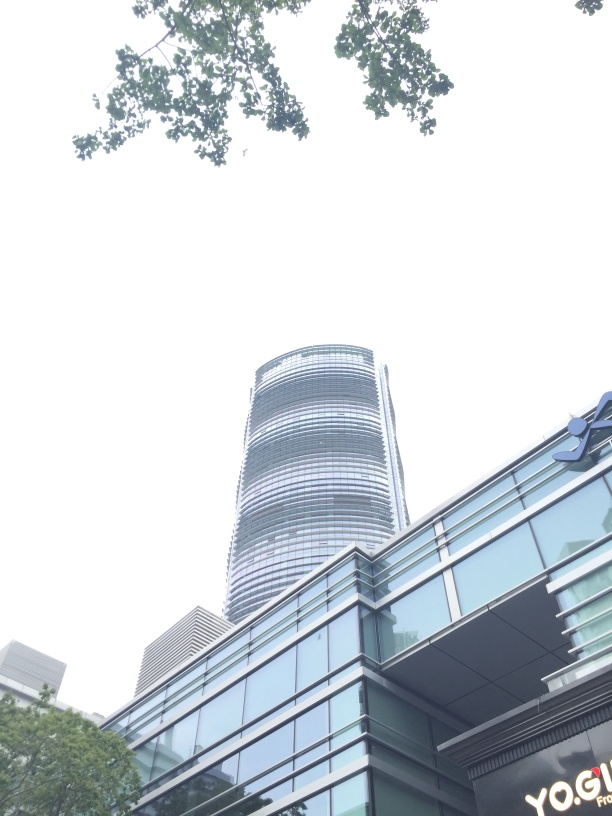Is the sharpness of the image good? The sharpness of the image appears to be moderate. Although the edges of the buildings and the tree leaves are reasonably distinct, the light overcast sky may be affecting the overall crispness of the image. Additional sharpness in the details of the building's facade and foliage could further improve the image quality. 